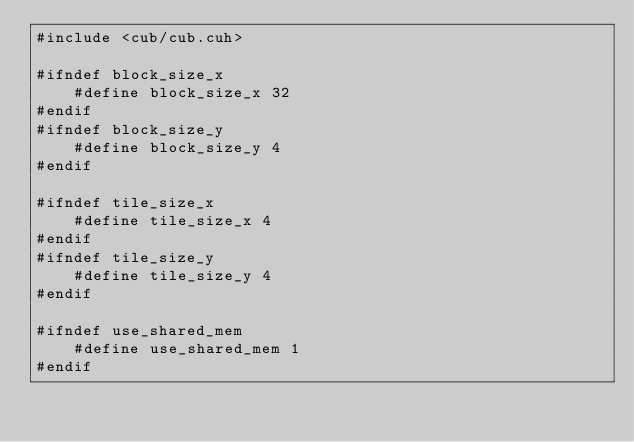<code> <loc_0><loc_0><loc_500><loc_500><_Cuda_>#include <cub/cub.cuh>

#ifndef block_size_x
    #define block_size_x 32
#endif
#ifndef block_size_y
    #define block_size_y 4
#endif

#ifndef tile_size_x
    #define tile_size_x 4
#endif
#ifndef tile_size_y
    #define tile_size_y 4
#endif

#ifndef use_shared_mem
    #define use_shared_mem 1
#endif
</code> 